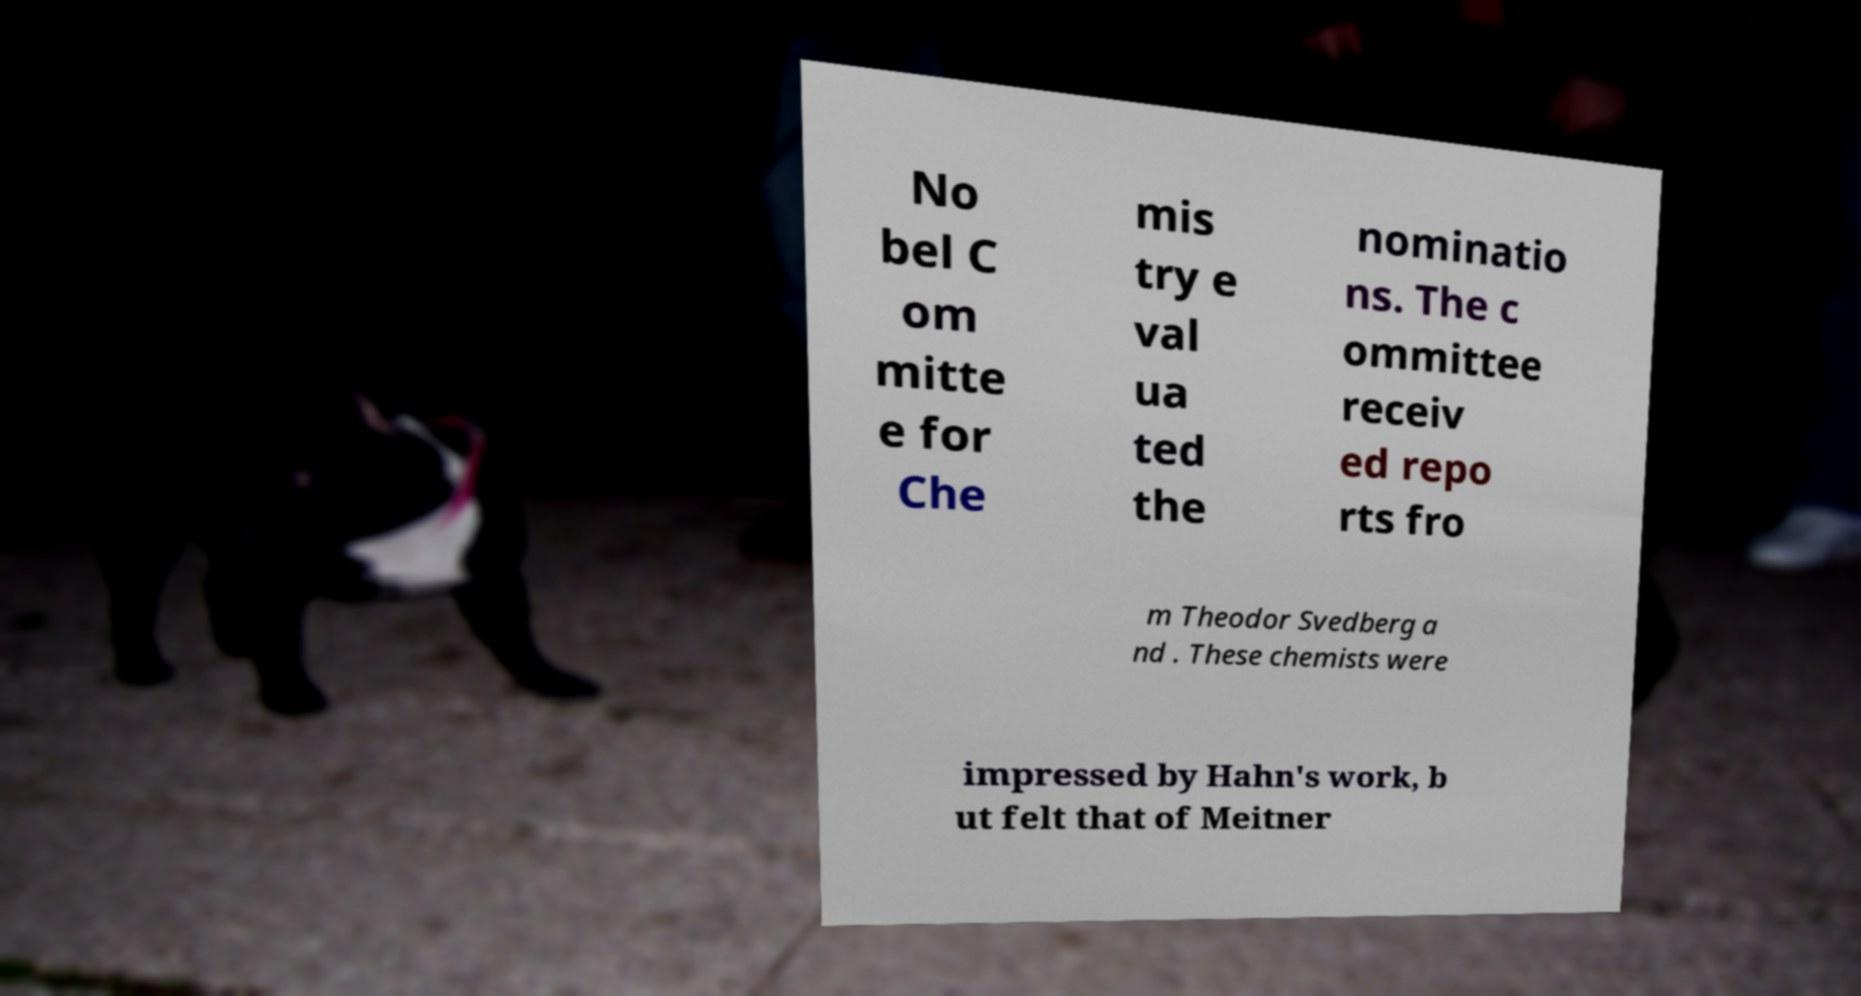Could you assist in decoding the text presented in this image and type it out clearly? No bel C om mitte e for Che mis try e val ua ted the nominatio ns. The c ommittee receiv ed repo rts fro m Theodor Svedberg a nd . These chemists were impressed by Hahn's work, b ut felt that of Meitner 